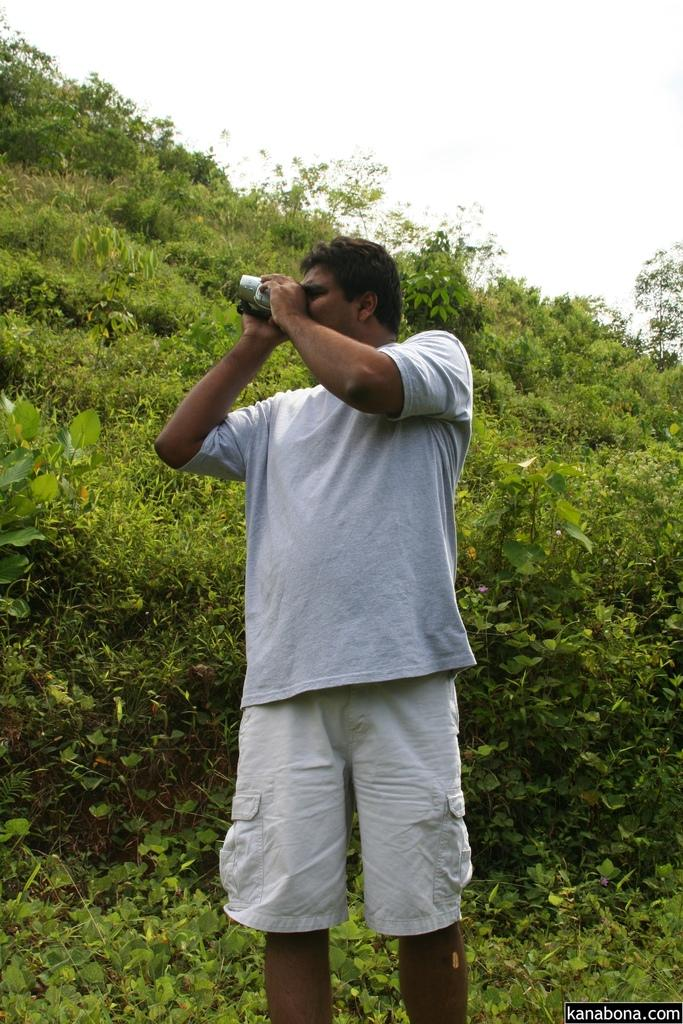Who is the main subject in the image? There is a man in the center of the image. What is the man doing in the image? The man is taking a photo. What can be seen in the background or surrounding the man in the image? There are plants around the area of the image. What type of suit is the man wearing in the image? There is no information about the man's clothing in the image, so we cannot determine if he is wearing a suit or not. Can you see the seashore in the image? No, the image does not show a seashore; it features a man taking a photo with plants in the background. What color is the man's collar in the image? There is no information about the man's collar in the image, so we cannot determine its color. 